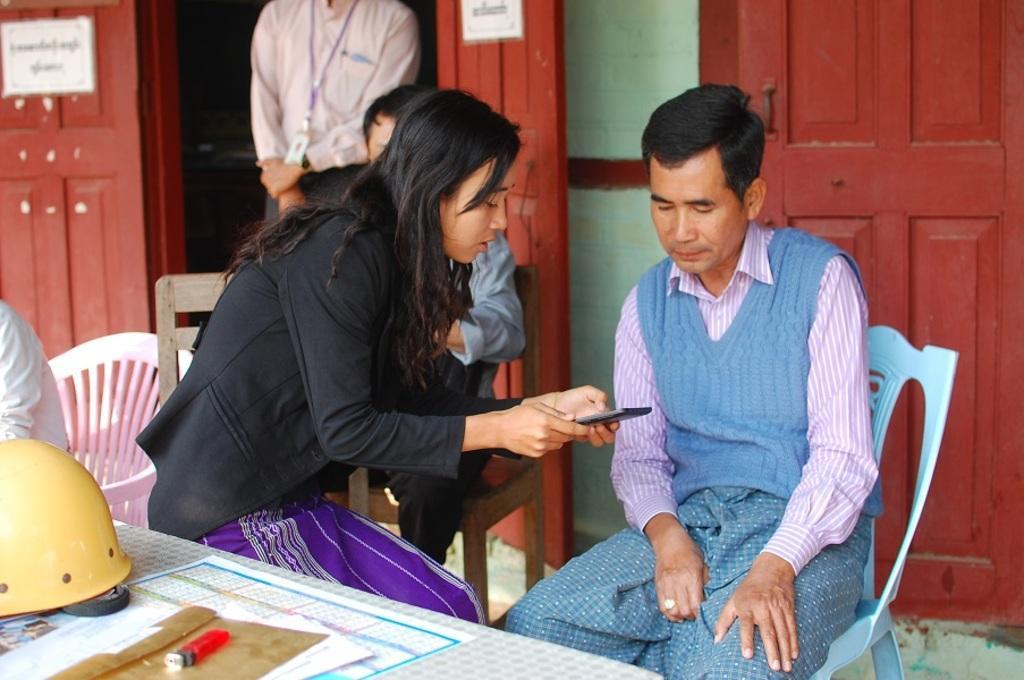Can you describe this image briefly? In the foreground of this image, there is a table on which helmet, calendar, papers and lighter on it. In the background, there is a woman holding a mobile like an object in her hand and a man sitting on the chair. Behind them, there are two men sitting on the chairs, a man standing, few red color doors and a wall. 